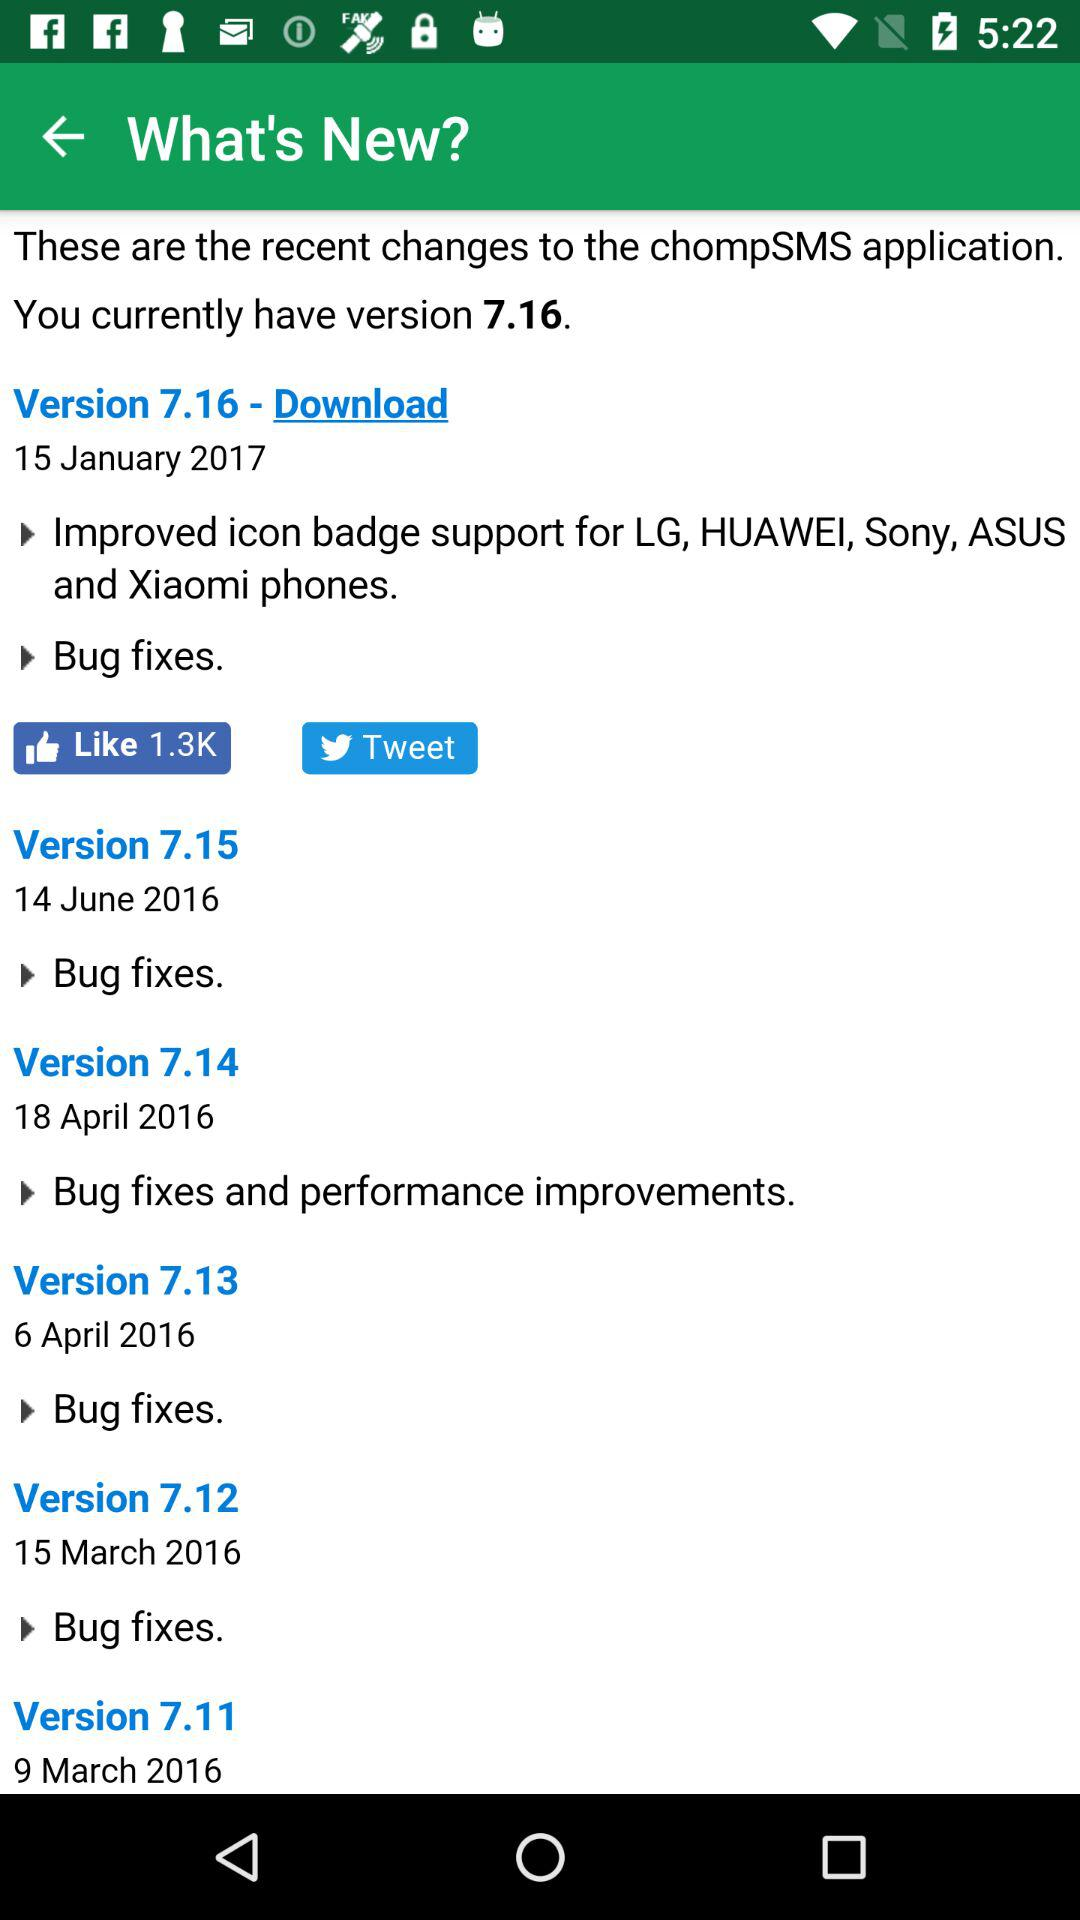On which devices is version 7.16 supported? Version 7.16 is supported on LG, Huawei, Sony, ASUS and Xiaomi devices. 